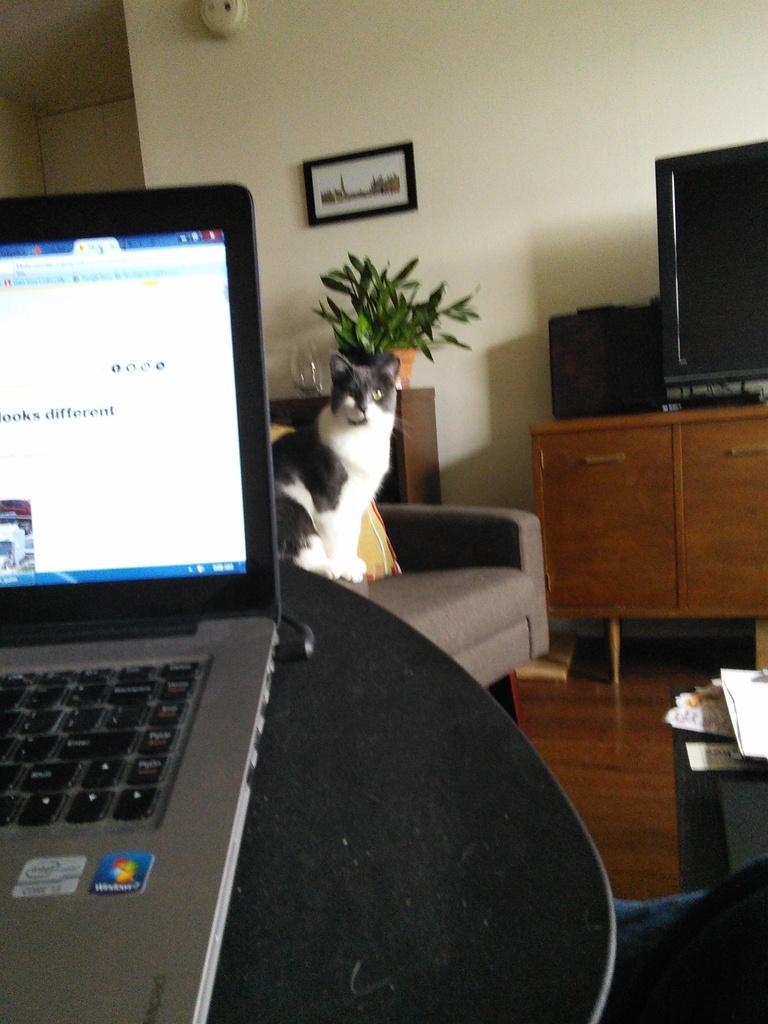Describe this image in one or two sentences. In the image we can see there is a cat who is sitting on chair and on the table there is a laptop and on the wall there is photo frame. 